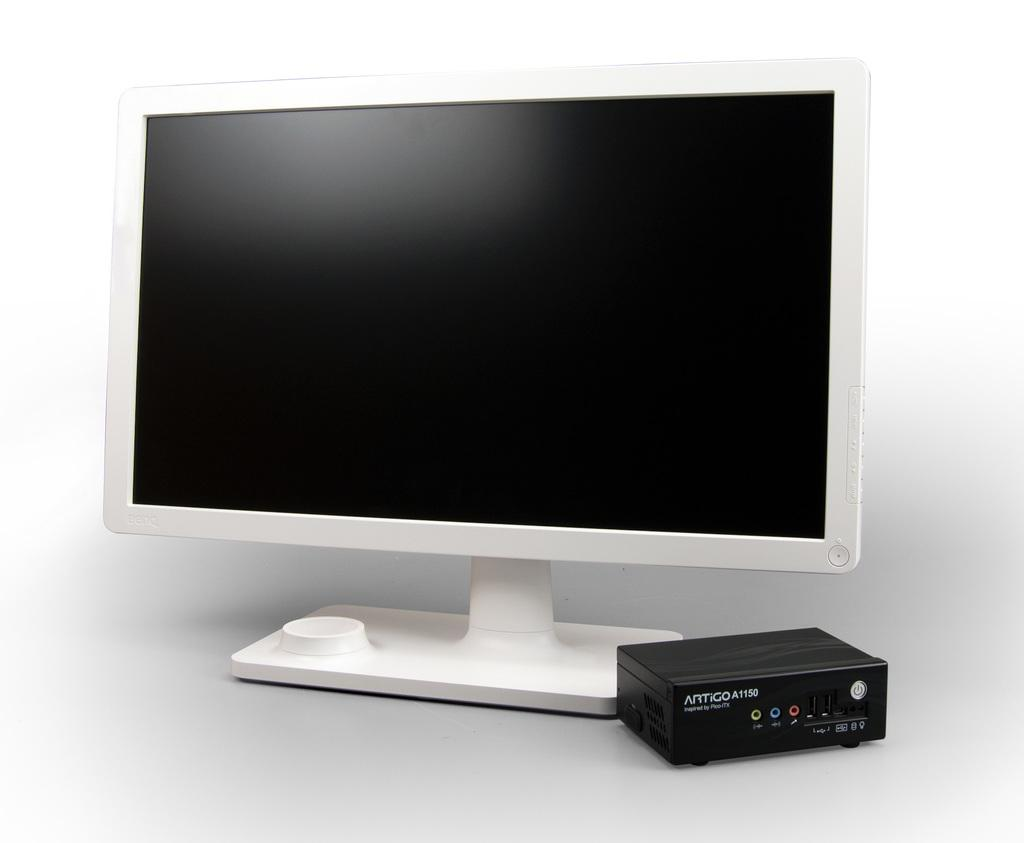Provide a one-sentence caption for the provided image. AN ALL IN ONE COMPUTER MONITOR AND BLACK BOX NETWORK. 